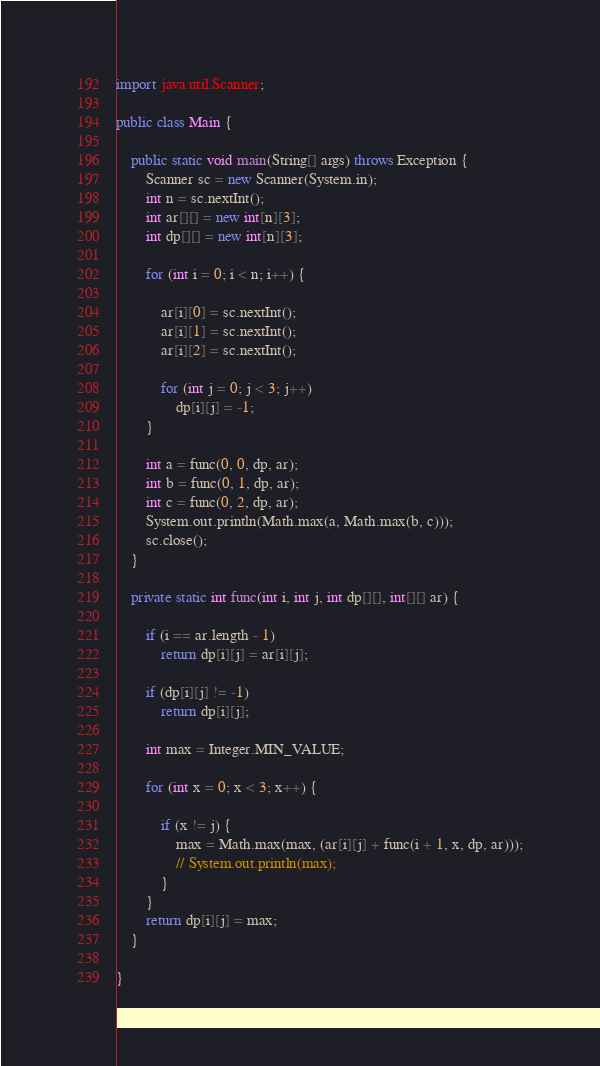<code> <loc_0><loc_0><loc_500><loc_500><_Java_>

import java.util.Scanner;

public class Main {

	public static void main(String[] args) throws Exception {
		Scanner sc = new Scanner(System.in);
		int n = sc.nextInt();
		int ar[][] = new int[n][3];
		int dp[][] = new int[n][3];

		for (int i = 0; i < n; i++) {

			ar[i][0] = sc.nextInt();
			ar[i][1] = sc.nextInt();
			ar[i][2] = sc.nextInt();

			for (int j = 0; j < 3; j++)
				dp[i][j] = -1;
		}

		int a = func(0, 0, dp, ar);
		int b = func(0, 1, dp, ar);
		int c = func(0, 2, dp, ar);
		System.out.println(Math.max(a, Math.max(b, c)));
		sc.close();
	}

	private static int func(int i, int j, int dp[][], int[][] ar) {

		if (i == ar.length - 1)
			return dp[i][j] = ar[i][j];

		if (dp[i][j] != -1)
			return dp[i][j];

		int max = Integer.MIN_VALUE;

		for (int x = 0; x < 3; x++) {

			if (x != j) {
				max = Math.max(max, (ar[i][j] + func(i + 1, x, dp, ar)));
				// System.out.println(max);
			}
		}
		return dp[i][j] = max;
	}

}</code> 